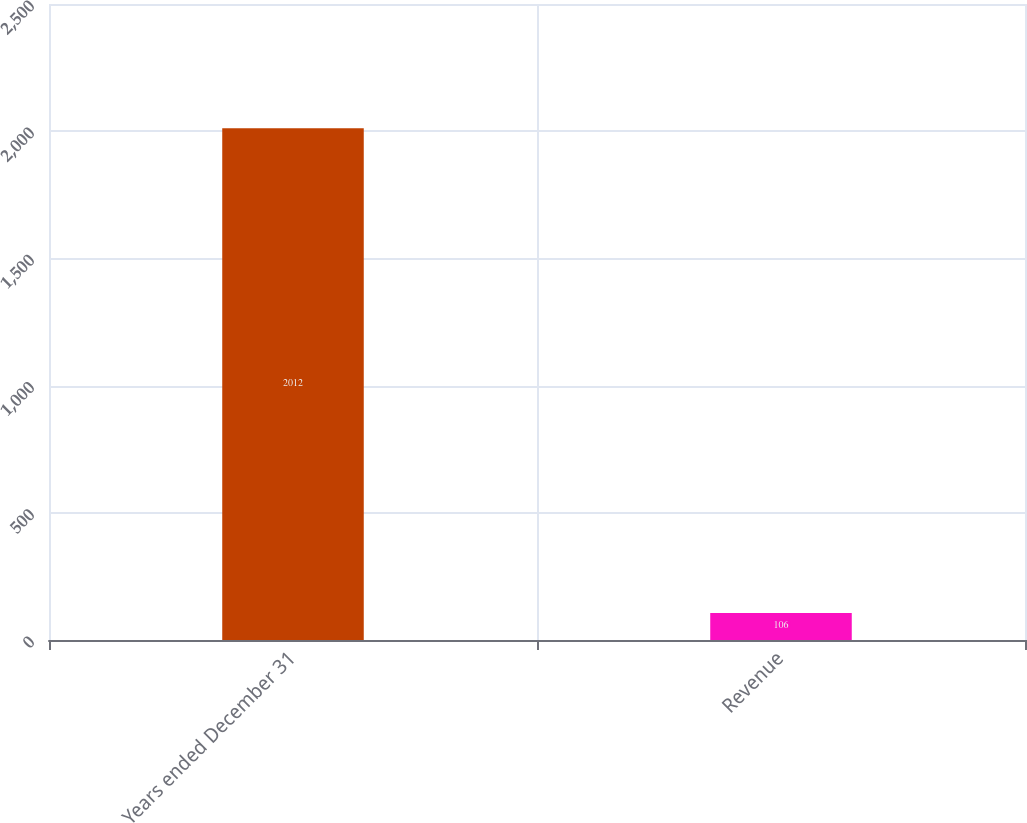<chart> <loc_0><loc_0><loc_500><loc_500><bar_chart><fcel>Years ended December 31<fcel>Revenue<nl><fcel>2012<fcel>106<nl></chart> 